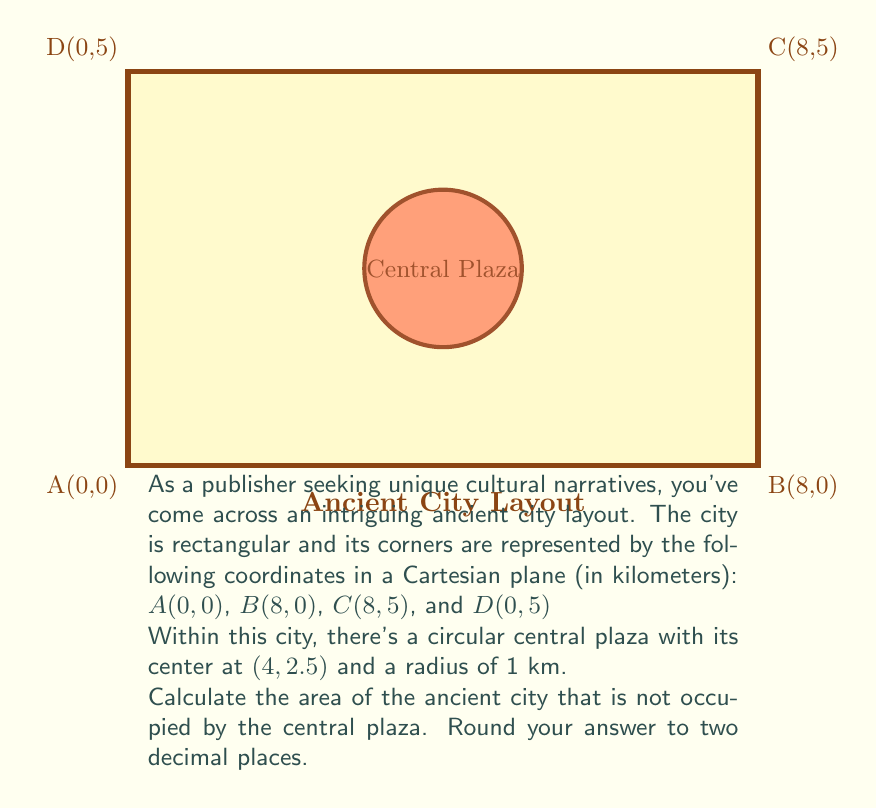Give your solution to this math problem. To solve this problem, we'll follow these steps:

1) Calculate the area of the entire rectangular city:
   $$A_{rectangle} = length \times width = 8 \times 5 = 40 \text{ km}^2$$

2) Calculate the area of the circular central plaza:
   $$A_{circle} = \pi r^2 = \pi \times 1^2 = \pi \text{ km}^2$$

3) Subtract the area of the central plaza from the area of the rectangle:
   $$A_{city} = A_{rectangle} - A_{circle} = 40 - \pi \text{ km}^2$$

4) Calculate the final result:
   $$A_{city} = 40 - \pi \approx 40 - 3.14159 \approx 36.85841 \text{ km}^2$$

5) Round to two decimal places:
   $$A_{city} \approx 36.86 \text{ km}^2$$

This approach uses the Cartesian coordinate system to define the city's layout and incorporates basic geometric formulas to calculate the areas.
Answer: $36.86 \text{ km}^2$ 